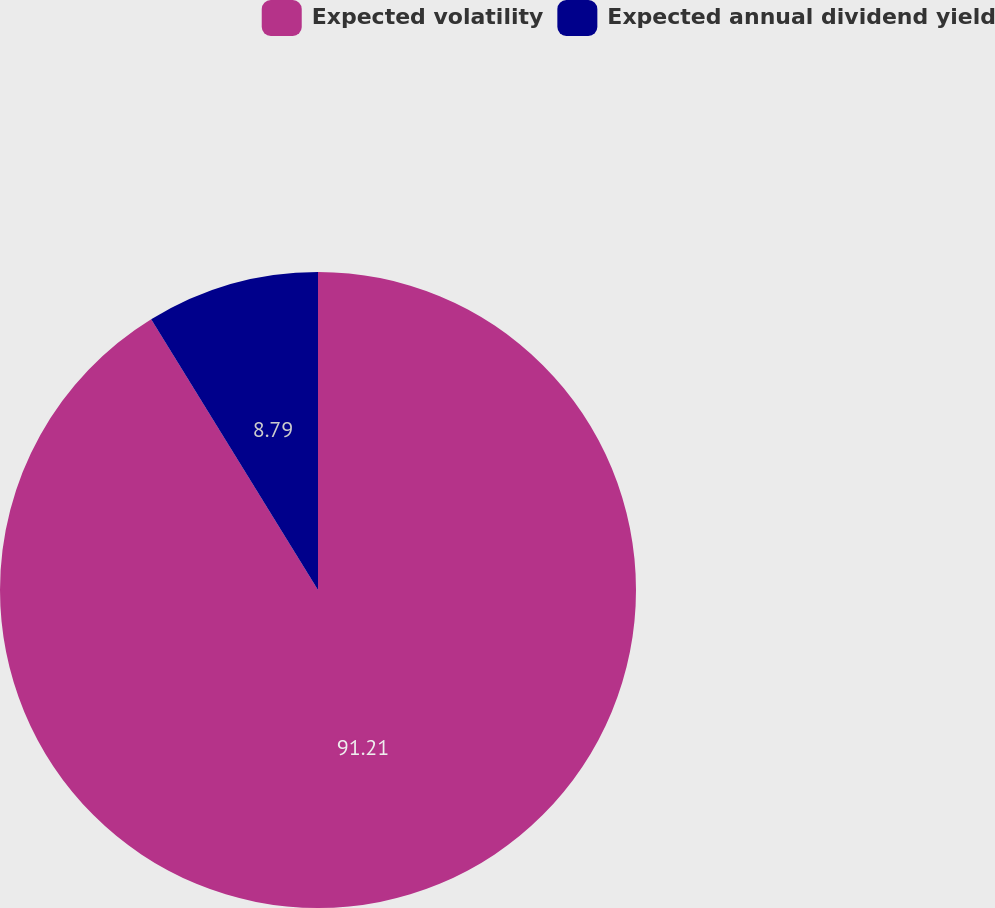Convert chart. <chart><loc_0><loc_0><loc_500><loc_500><pie_chart><fcel>Expected volatility<fcel>Expected annual dividend yield<nl><fcel>91.21%<fcel>8.79%<nl></chart> 